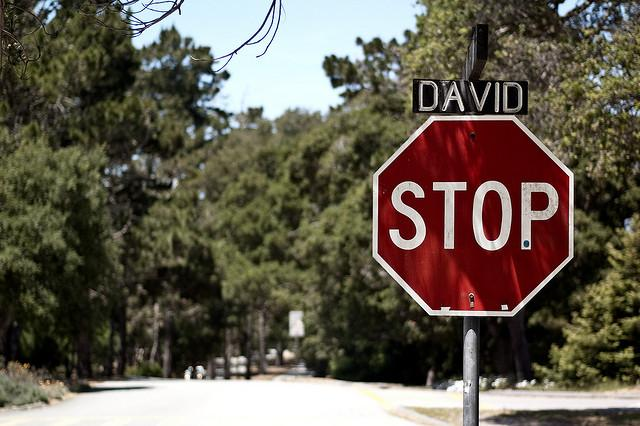What is the name of the street parallel to the stop sign?

Choices:
A) chestnut
B) washington
C) david
D) blackberry david 